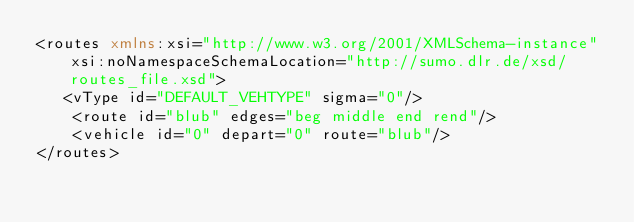Convert code to text. <code><loc_0><loc_0><loc_500><loc_500><_XML_><routes xmlns:xsi="http://www.w3.org/2001/XMLSchema-instance" xsi:noNamespaceSchemaLocation="http://sumo.dlr.de/xsd/routes_file.xsd">
   <vType id="DEFAULT_VEHTYPE" sigma="0"/>
    <route id="blub" edges="beg middle end rend"/>
    <vehicle id="0" depart="0" route="blub"/>
</routes>
</code> 